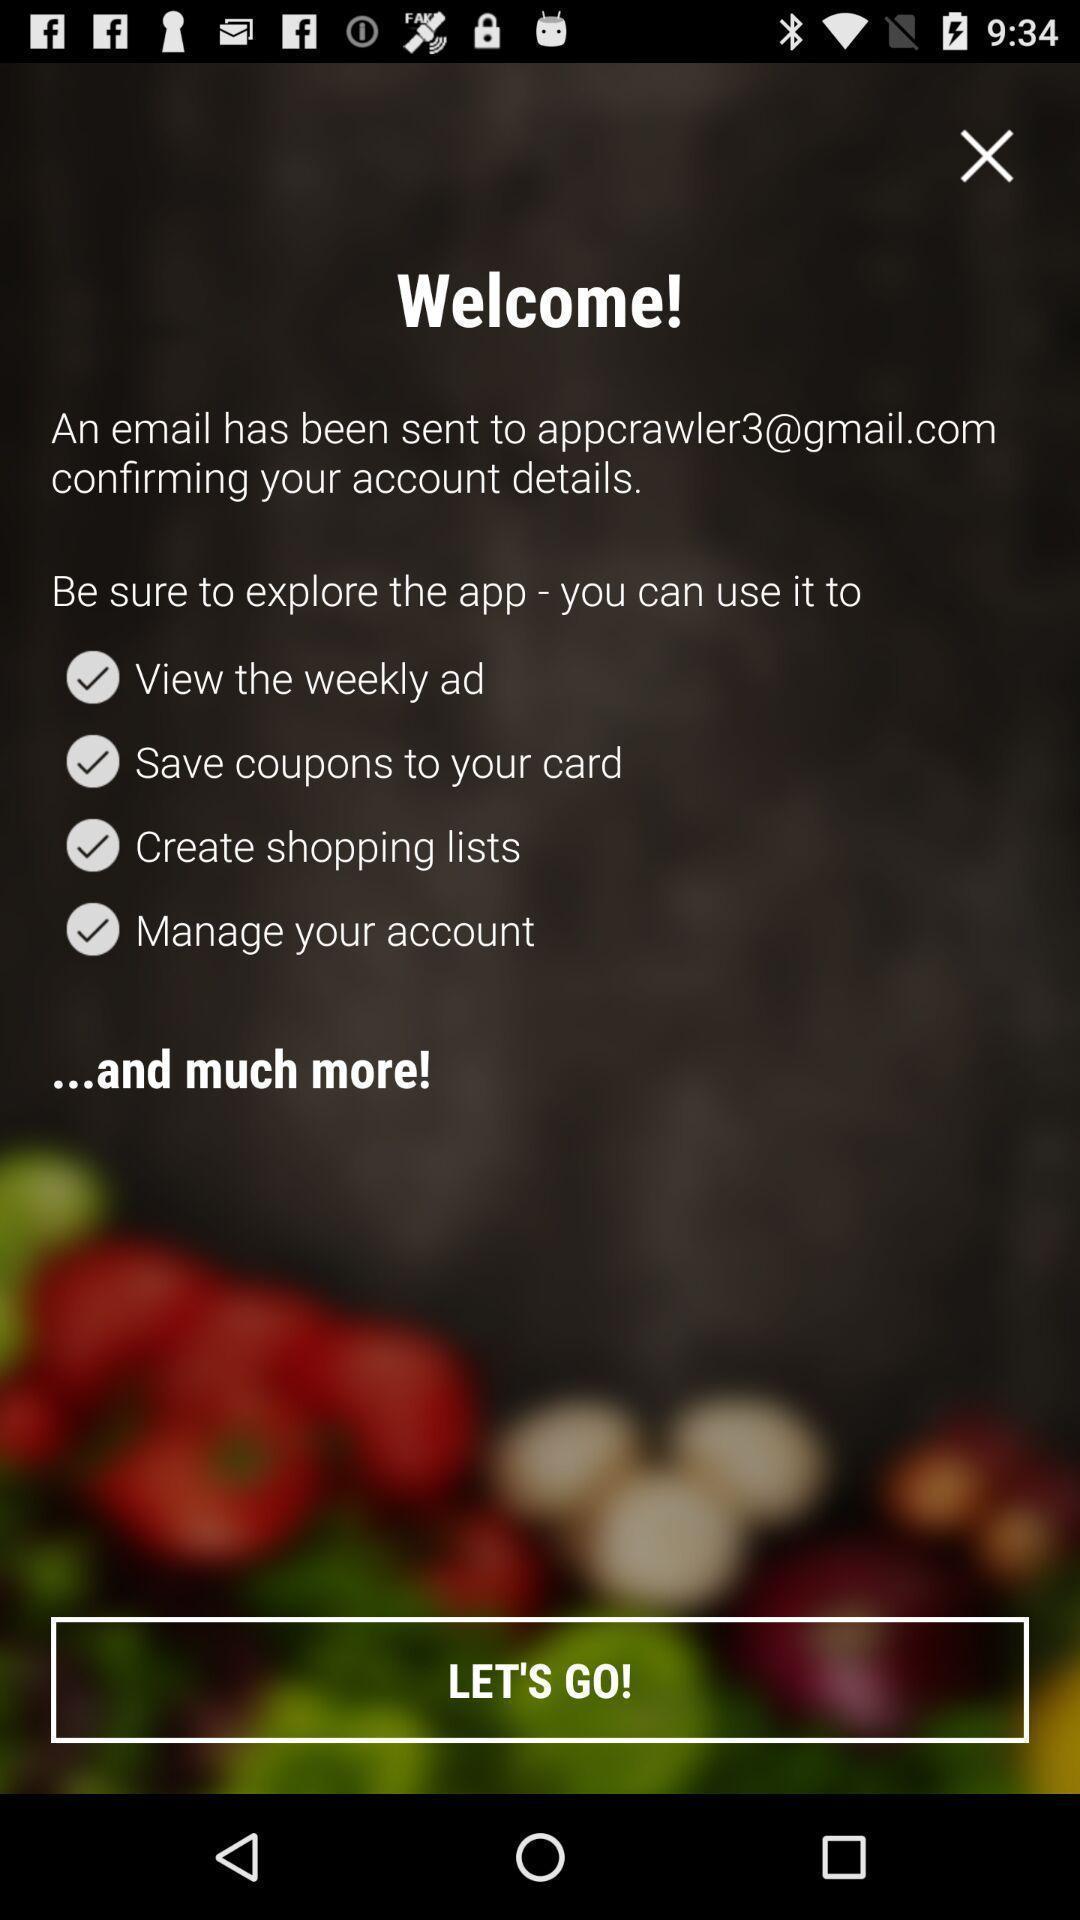Tell me about the visual elements in this screen capture. Welcome screen. 